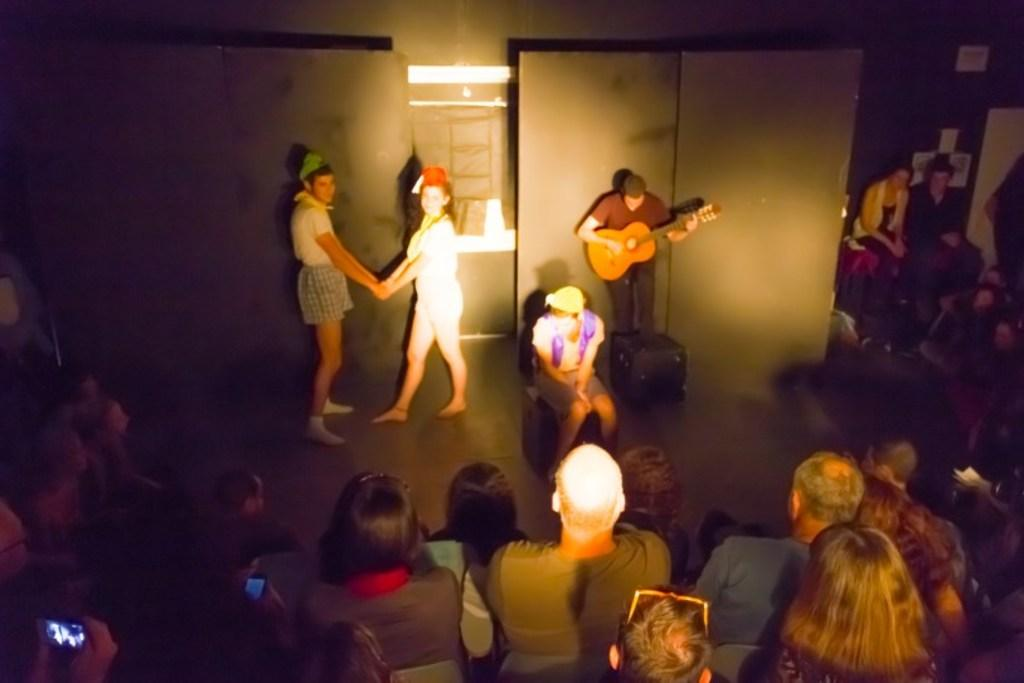What can be seen in the background of the image? There is a wall in the image. What are the people in the image doing? The people are standing in the image. Can you describe the man in the image? The man is holding a guitar in the image. What type of crack is visible on the side of the van in the image? There is no van present in the image, so there is no crack to describe. 